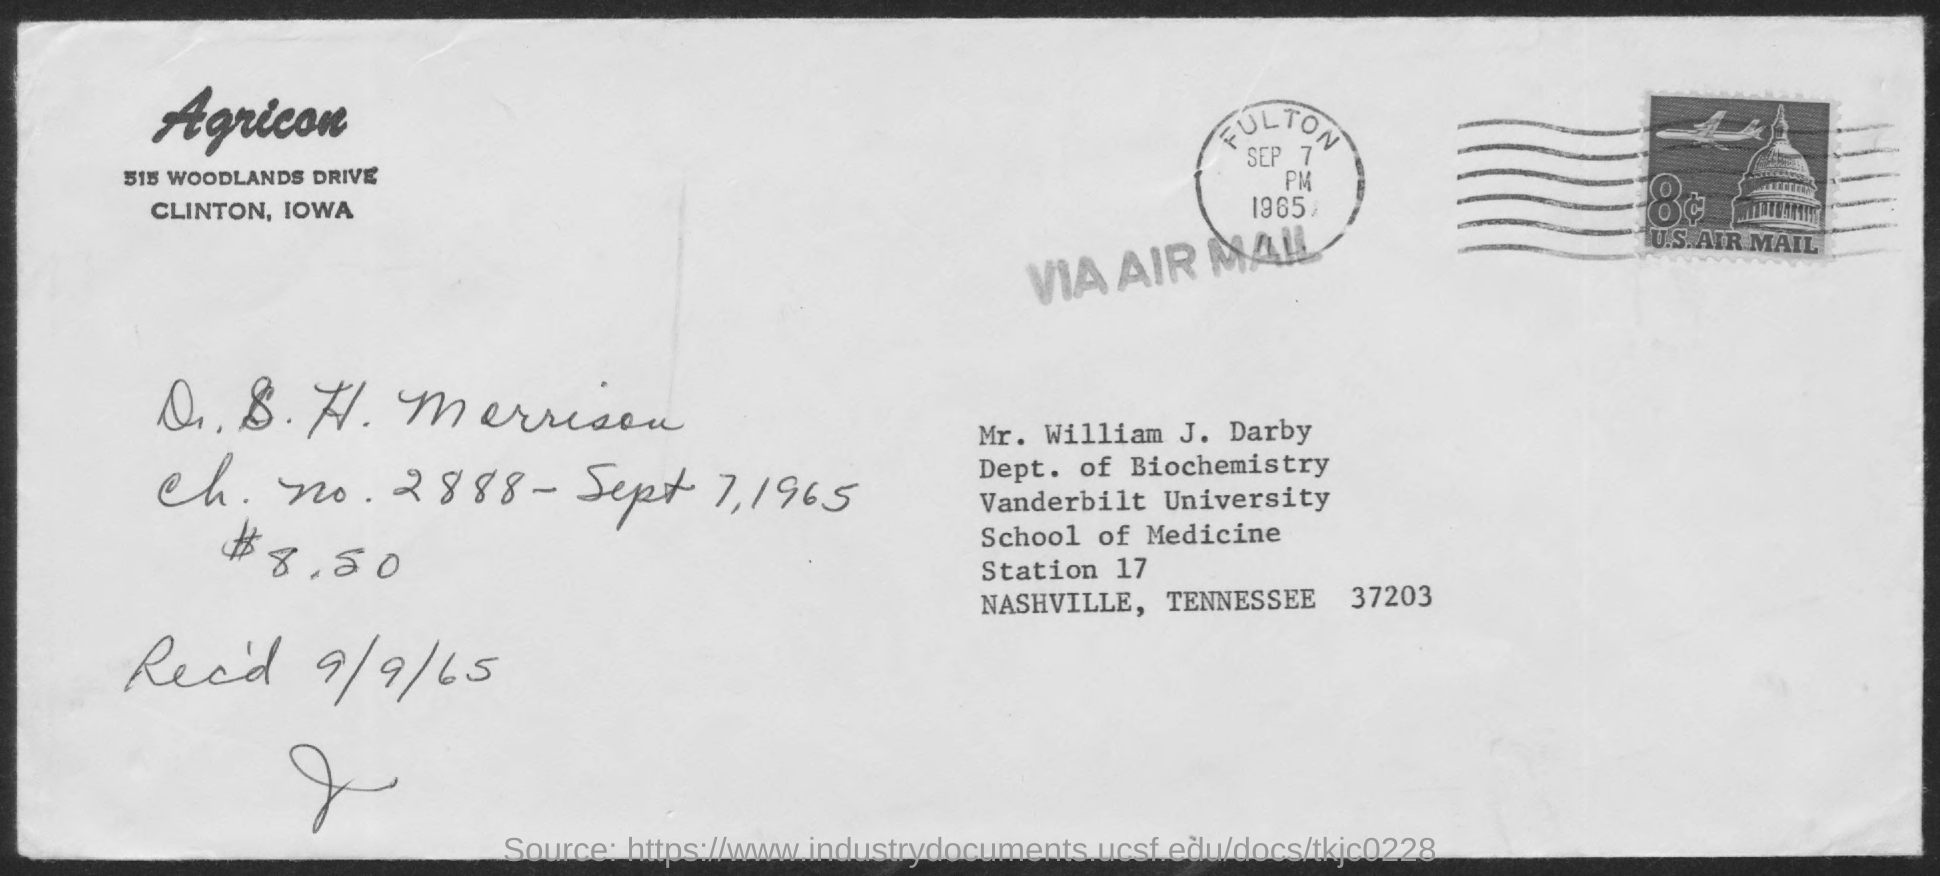To Whom is this letter addressed to?
Provide a succinct answer. Mr. William J. Darby. 